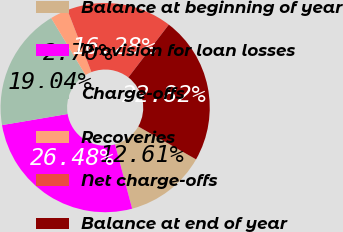Convert chart. <chart><loc_0><loc_0><loc_500><loc_500><pie_chart><fcel>Balance at beginning of year<fcel>Provision for loan losses<fcel>Charge-offs<fcel>Recoveries<fcel>Net charge-offs<fcel>Balance at end of year<nl><fcel>12.61%<fcel>26.48%<fcel>19.04%<fcel>2.76%<fcel>16.28%<fcel>22.82%<nl></chart> 